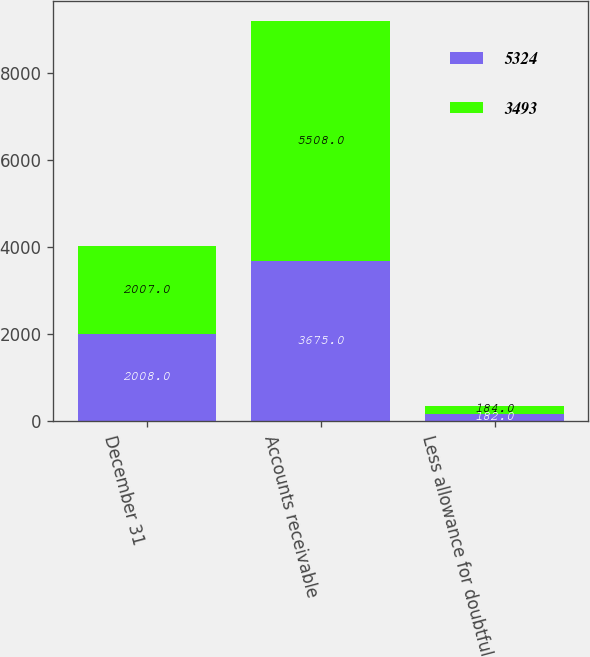Convert chart to OTSL. <chart><loc_0><loc_0><loc_500><loc_500><stacked_bar_chart><ecel><fcel>December 31<fcel>Accounts receivable<fcel>Less allowance for doubtful<nl><fcel>5324<fcel>2008<fcel>3675<fcel>182<nl><fcel>3493<fcel>2007<fcel>5508<fcel>184<nl></chart> 